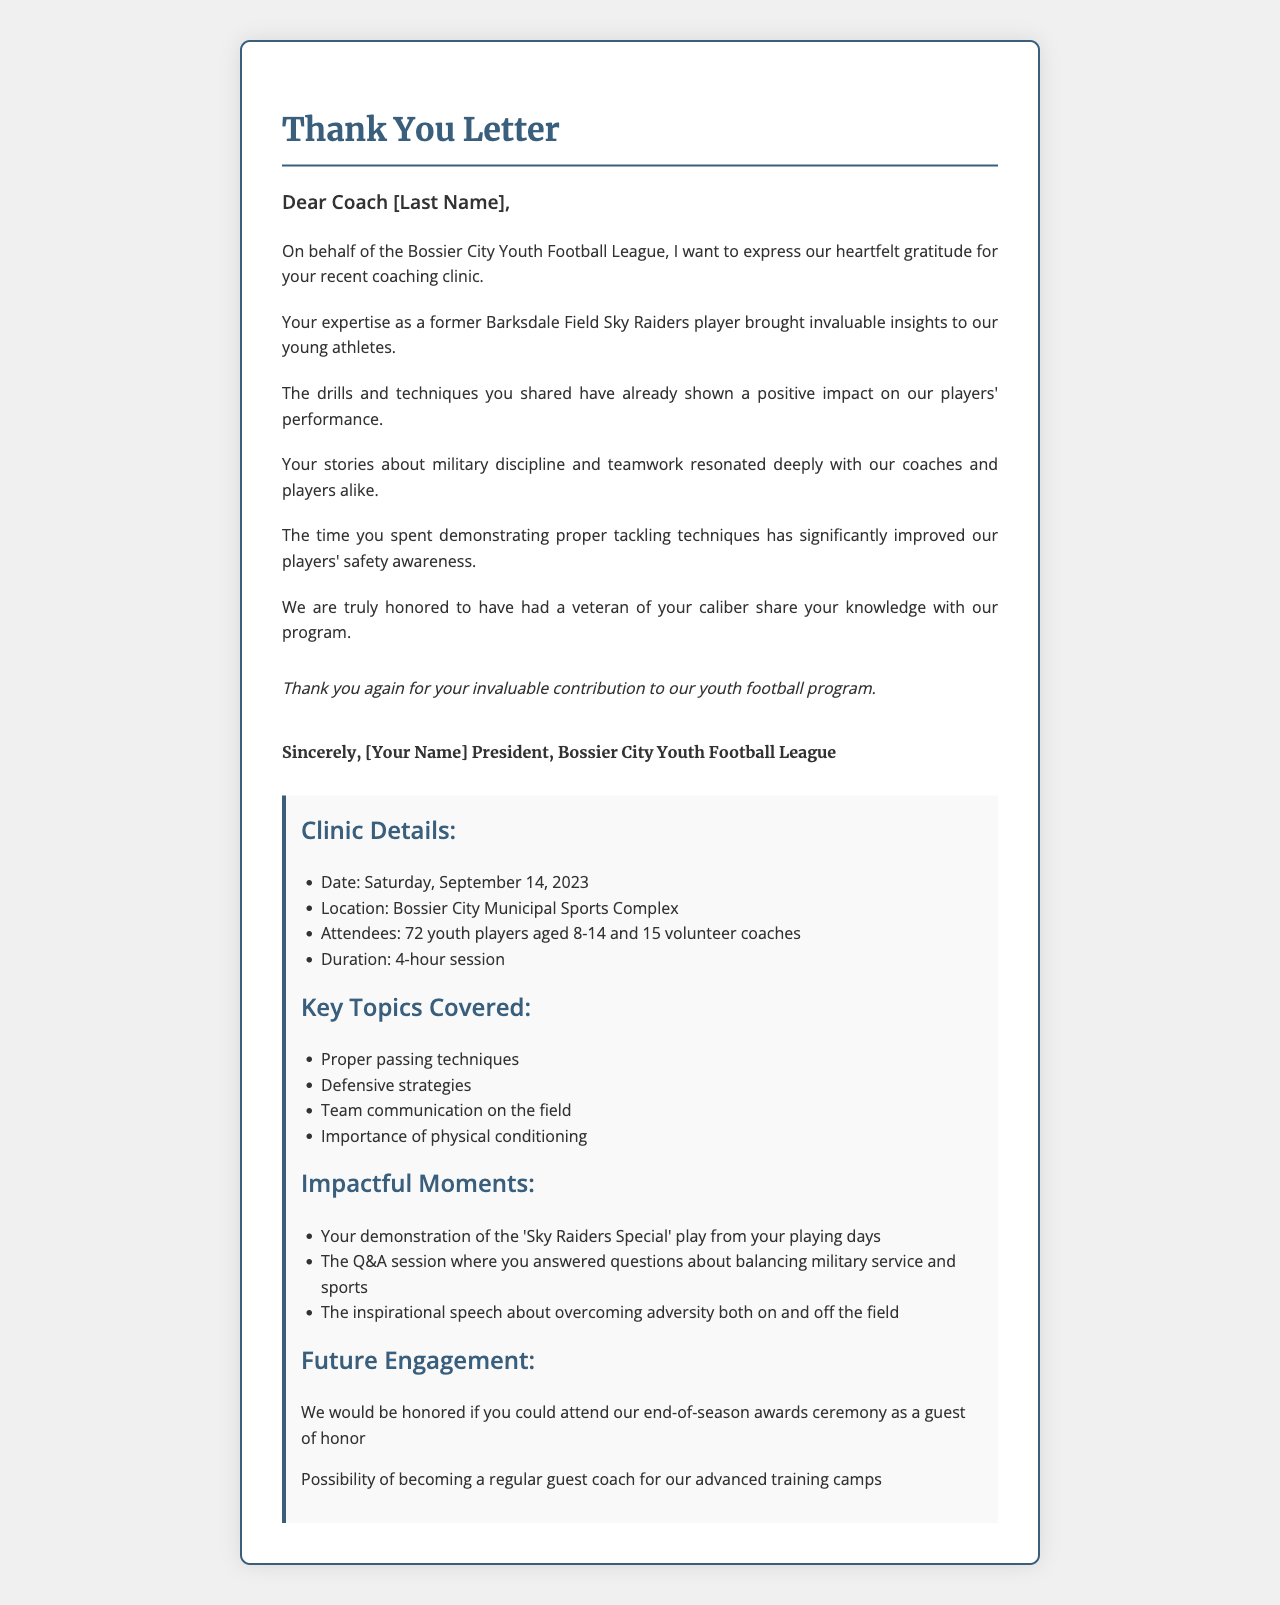What is the name of the youth football league? The name of the youth football league is explicitly stated in the document.
Answer: Bossier City Youth Football League What was the date of the coaching clinic? The specific date of the clinic is provided in the letter.
Answer: Saturday, September 14, 2023 How many young athletes attended the clinic? The attendance number for young athletes is detailed in the document.
Answer: 72 youth players What did the letter express gratitude for? The letter is primarily focused on expressing thanks for a specific event or contribution.
Answer: Recent coaching clinic What was one of the key topics covered during the clinic? The document lists several key topics; one can be picked as an example.
Answer: Proper passing techniques What impact did the clinic have on player safety? The impact on the players' safety awareness is discussed in the letter.
Answer: Significantly improved What role is the recipient invited to take at the end-of-season awards ceremony? The document contains an invitation for a specific role during an event.
Answer: Guest of honor What military rank did the coach hold? The document mentions the coach's military rank as part of his personal touches.
Answer: Retired Master Sergeant What is the name of the local football team mentioned in the letter? The community context section states the name of a local team.
Answer: Bossier City Bulldogs 